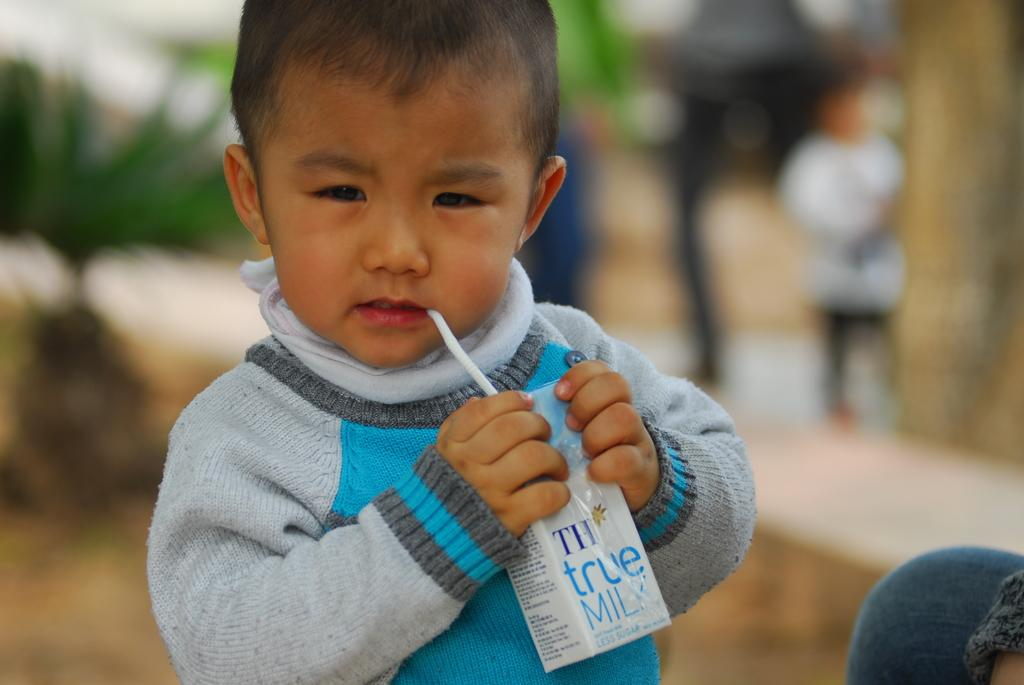Who is the main subject in the image? There is a child in the image. What is the child doing in the image? The child is drinking milk. What other object can be seen in the image besides the child? There is a plant visible in the image. Can you describe the background of the image? The background of the image is blurred. What is the aftermath of the shocking measure taken by the child in the image? There is no indication of any shocking measure taken by the child in the image; the child is simply drinking milk. 